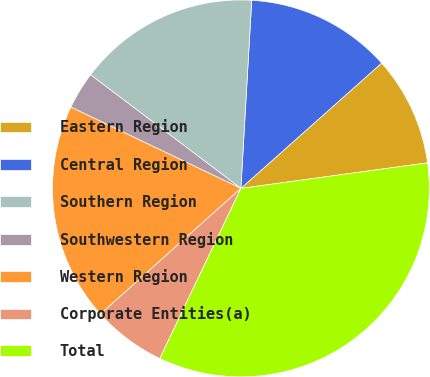<chart> <loc_0><loc_0><loc_500><loc_500><pie_chart><fcel>Eastern Region<fcel>Central Region<fcel>Southern Region<fcel>Southwestern Region<fcel>Western Region<fcel>Corporate Entities(a)<fcel>Total<nl><fcel>9.41%<fcel>12.51%<fcel>15.62%<fcel>3.2%<fcel>18.72%<fcel>6.3%<fcel>34.25%<nl></chart> 